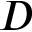<formula> <loc_0><loc_0><loc_500><loc_500>D</formula> 